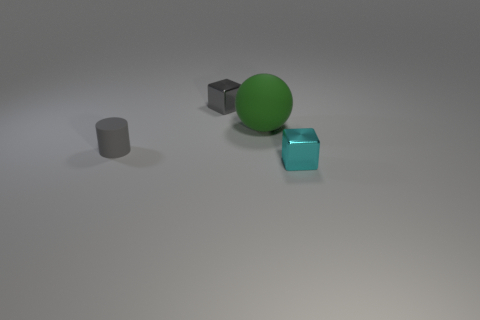Add 4 tiny metal cubes. How many objects exist? 8 Subtract 1 blocks. How many blocks are left? 1 Subtract all green blocks. Subtract all purple cylinders. How many blocks are left? 2 Subtract all gray blocks. How many brown cylinders are left? 0 Subtract all large cylinders. Subtract all green things. How many objects are left? 3 Add 2 gray matte objects. How many gray matte objects are left? 3 Add 1 tiny red cubes. How many tiny red cubes exist? 1 Subtract 0 brown balls. How many objects are left? 4 Subtract all cylinders. How many objects are left? 3 